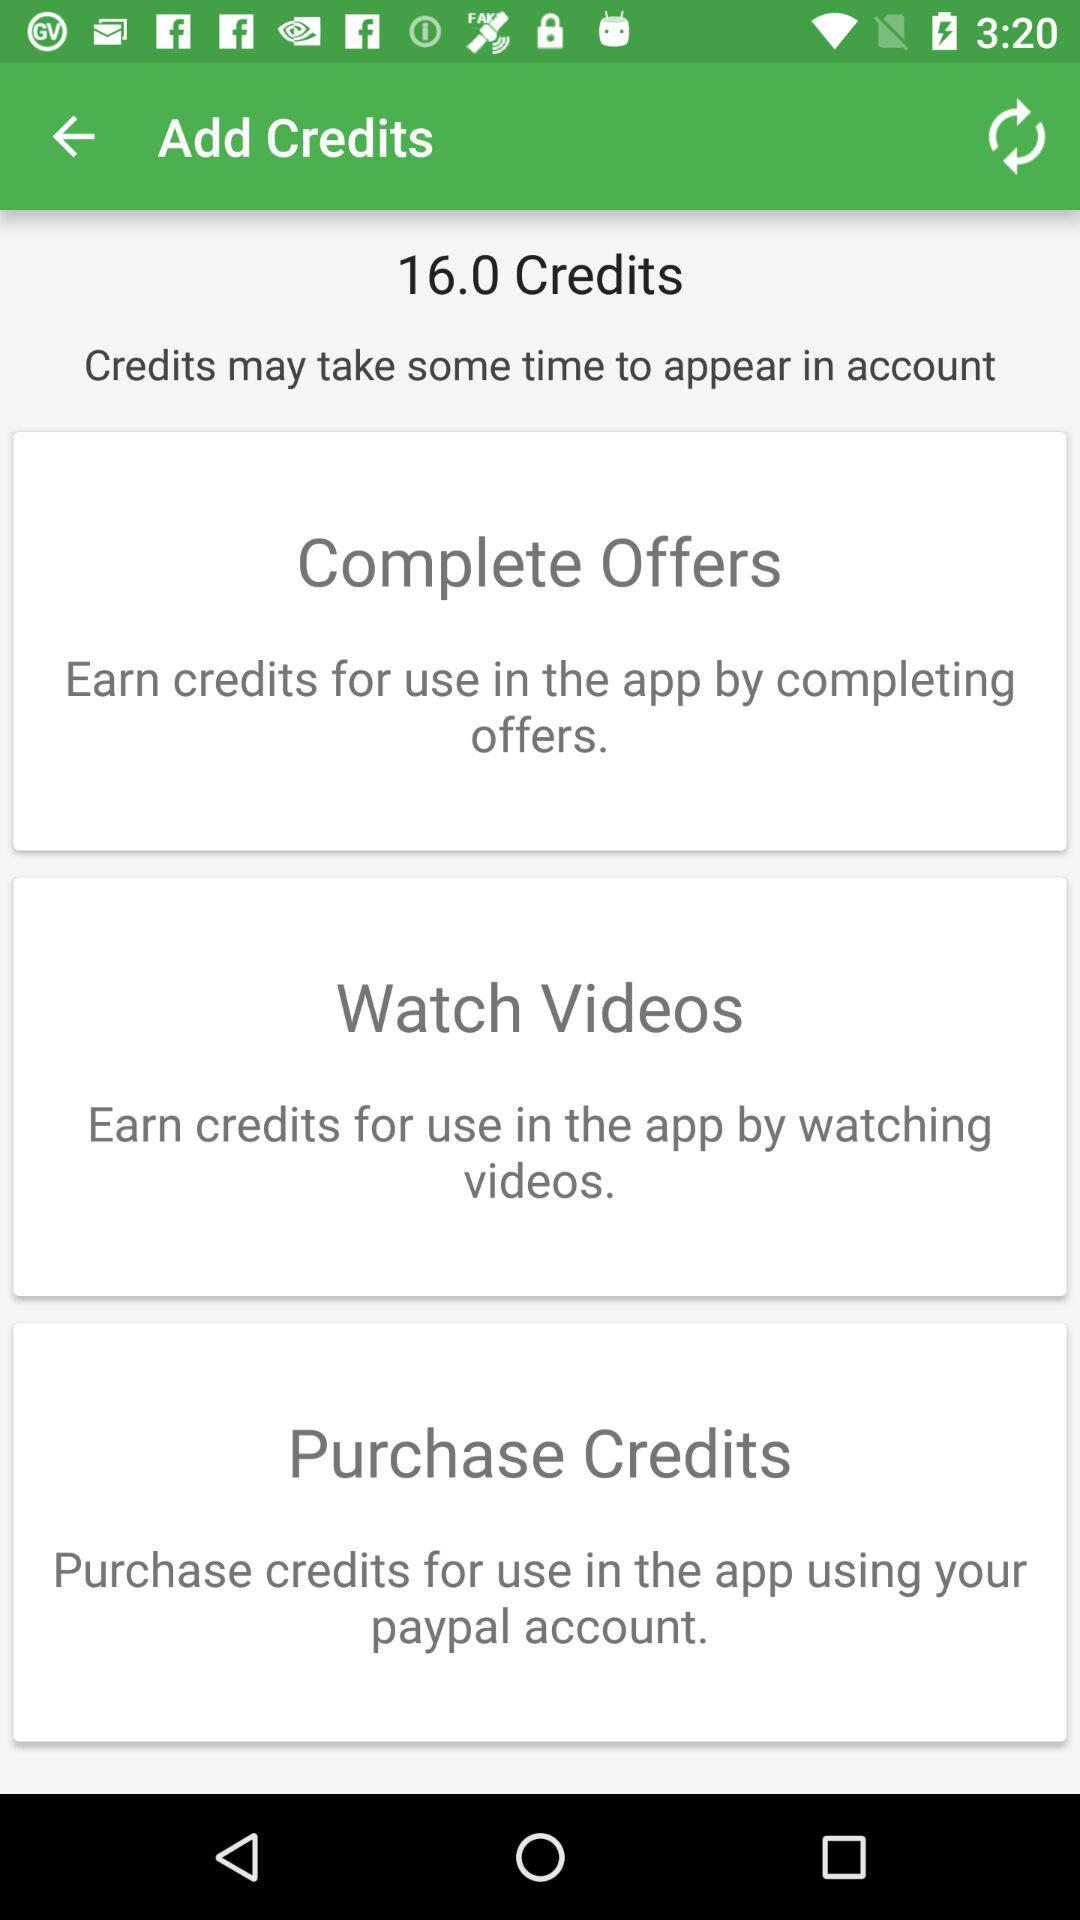How many ways can I earn credits?
Answer the question using a single word or phrase. 3 